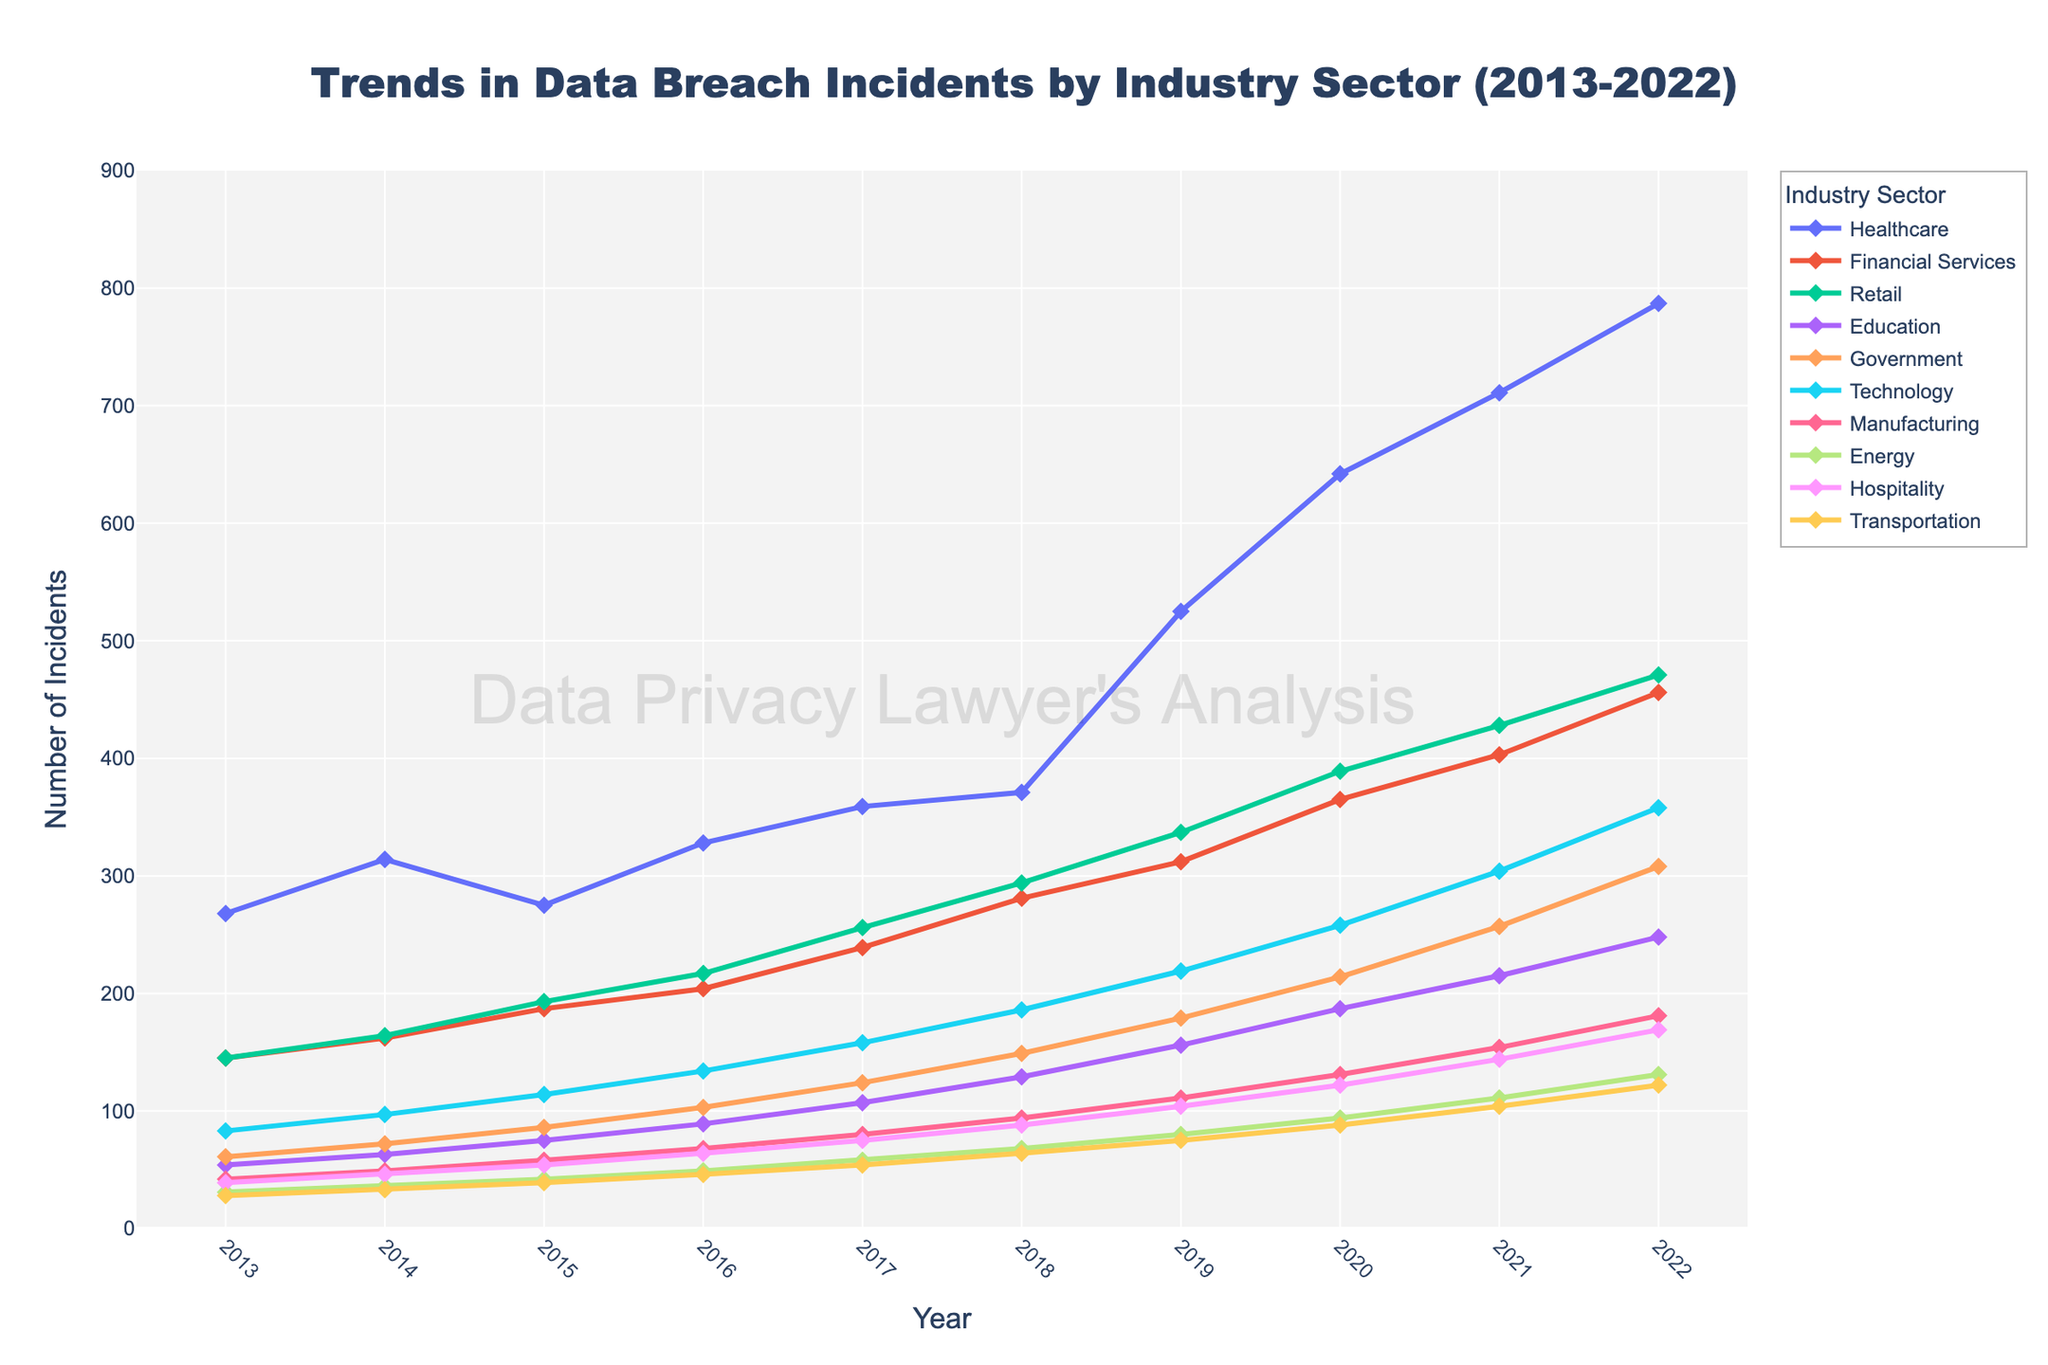Which industry experienced the highest number of data breach incidents in 2022? Looking at the spikes in the final year of the chart, the healthcare industry shows the highest peak among all the represented industries.
Answer: Healthcare How many more data breach incidents did the healthcare sector have compared to the financial services sector in 2022? According to the chart, the healthcare sector had 787 incidents in 2022, and the financial services sector had 456. The difference is calculated as 787 - 456.
Answer: 331 In which year did the technology sector see over 100 data breach incidents for the first time? By following the trend line for the technology sector, we see that it crosses the 100 incident mark between 2015 and 2016. Looking at the approximate values, it is in 2016.
Answer: 2016 Which industry showed the most consistent year-over-year growth in data breach incidents from 2013 to 2022? The financial services industry shows a consistent upward trend without any visible drops or major fluctuations throughout the entire timeframe.
Answer: Financial Services What is the total number of data breach incidents in the retail sector from 2020 to 2022? Counting the incidents in the retail sector for the years 2020, 2021, and 2022 respectively, we sum 389 + 428 + 471. The total is 1288.
Answer: 1288 How does the rate of increase in incidents for the healthcare sector compare to the energy sector between 2018 and 2022? The healthcare sector increased from 371 incidents in 2018 to 787 in 2022, a growth of 416 incidents. The energy sector increased from 68 to 131, a growth of 63 incidents. The rate of increase for healthcare is significantly higher.
Answer: Healthcare sector's rate is significantly higher Between which two consecutive years did the government sector see its highest increase in data breach incidents? By examining the line for the government sector, the steepest upward change happens between 2019 and 2020. Observably, it increases from 179 to 214.
Answer: 2019 to 2020 What can be inferred about the relative frequency of data breaches in the hospitality sector compared to the transportation sector over the decade? By analyzing the trend lines for both sectors, it's visible that the hospitality sector consistently shows higher numbers than the transportation sector throughout all years.
Answer: Hospitality sector has more frequent breaches 